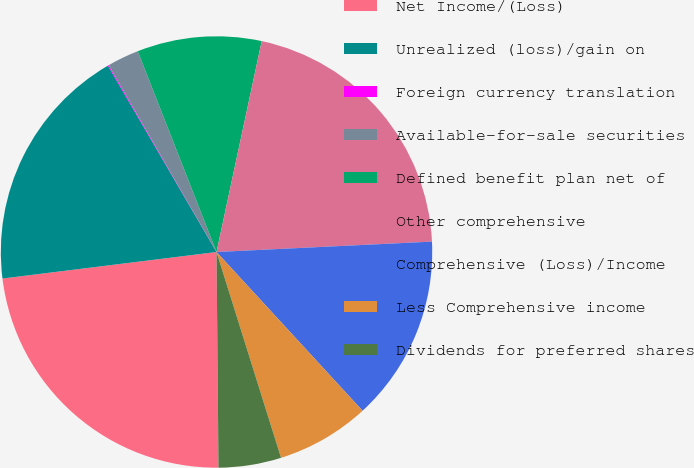Convert chart to OTSL. <chart><loc_0><loc_0><loc_500><loc_500><pie_chart><fcel>Net Income/(Loss)<fcel>Unrealized (loss)/gain on<fcel>Foreign currency translation<fcel>Available-for-sale securities<fcel>Defined benefit plan net of<fcel>Other comprehensive<fcel>Comprehensive (Loss)/Income<fcel>Less Comprehensive income<fcel>Dividends for preferred shares<nl><fcel>23.18%<fcel>18.56%<fcel>0.07%<fcel>2.38%<fcel>9.31%<fcel>20.87%<fcel>13.93%<fcel>7.0%<fcel>4.69%<nl></chart> 